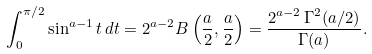Convert formula to latex. <formula><loc_0><loc_0><loc_500><loc_500>\int _ { 0 } ^ { \pi / 2 } \sin ^ { a - 1 } t \, d t = 2 ^ { a - 2 } B \left ( \frac { a } { 2 } , \frac { a } { 2 } \right ) = \frac { 2 ^ { a - 2 } \, \Gamma ^ { 2 } ( a / 2 ) } { \Gamma ( a ) } .</formula> 